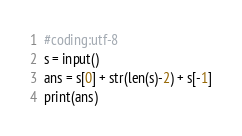<code> <loc_0><loc_0><loc_500><loc_500><_Python_>#coding:utf-8
s = input()
ans = s[0] + str(len(s)-2) + s[-1]
print(ans)</code> 